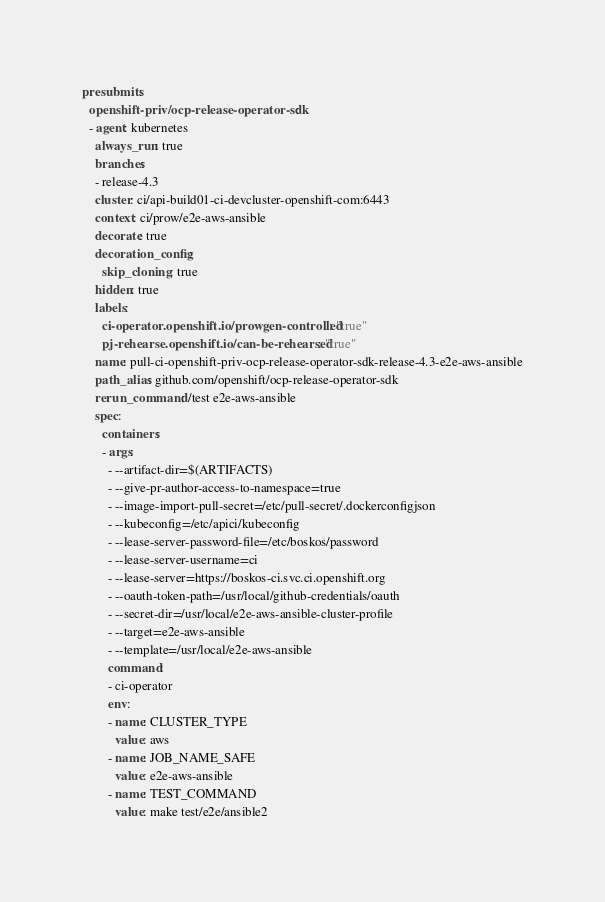Convert code to text. <code><loc_0><loc_0><loc_500><loc_500><_YAML_>presubmits:
  openshift-priv/ocp-release-operator-sdk:
  - agent: kubernetes
    always_run: true
    branches:
    - release-4.3
    cluster: ci/api-build01-ci-devcluster-openshift-com:6443
    context: ci/prow/e2e-aws-ansible
    decorate: true
    decoration_config:
      skip_cloning: true
    hidden: true
    labels:
      ci-operator.openshift.io/prowgen-controlled: "true"
      pj-rehearse.openshift.io/can-be-rehearsed: "true"
    name: pull-ci-openshift-priv-ocp-release-operator-sdk-release-4.3-e2e-aws-ansible
    path_alias: github.com/openshift/ocp-release-operator-sdk
    rerun_command: /test e2e-aws-ansible
    spec:
      containers:
      - args:
        - --artifact-dir=$(ARTIFACTS)
        - --give-pr-author-access-to-namespace=true
        - --image-import-pull-secret=/etc/pull-secret/.dockerconfigjson
        - --kubeconfig=/etc/apici/kubeconfig
        - --lease-server-password-file=/etc/boskos/password
        - --lease-server-username=ci
        - --lease-server=https://boskos-ci.svc.ci.openshift.org
        - --oauth-token-path=/usr/local/github-credentials/oauth
        - --secret-dir=/usr/local/e2e-aws-ansible-cluster-profile
        - --target=e2e-aws-ansible
        - --template=/usr/local/e2e-aws-ansible
        command:
        - ci-operator
        env:
        - name: CLUSTER_TYPE
          value: aws
        - name: JOB_NAME_SAFE
          value: e2e-aws-ansible
        - name: TEST_COMMAND
          value: make test/e2e/ansible2</code> 